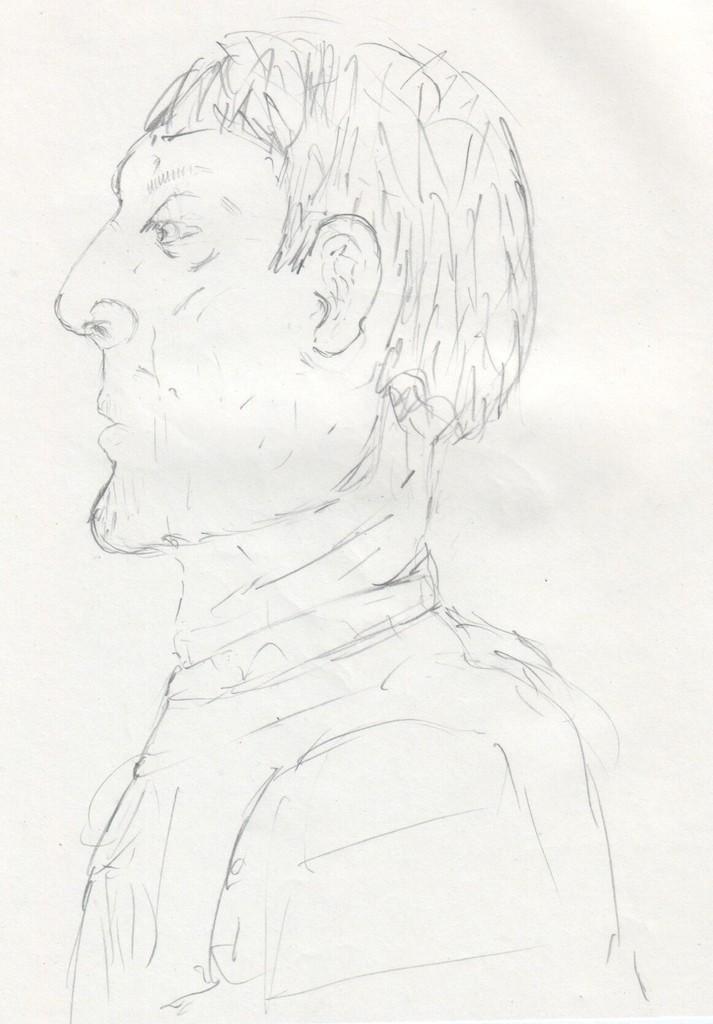In one or two sentences, can you explain what this image depicts? In this image, this looks like a paper. I think this is the pencil art of a person. 